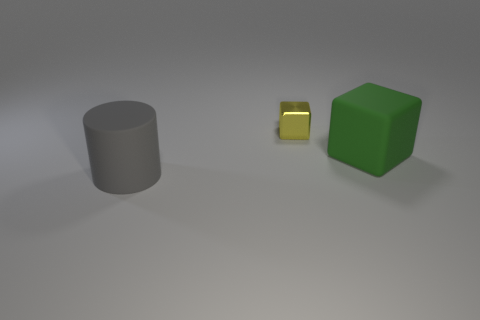There is a big thing on the right side of the matte cylinder; is it the same shape as the tiny yellow metallic object behind the cylinder?
Offer a very short reply. Yes. Are there any tiny purple rubber things?
Make the answer very short. No. There is another object that is the same shape as the small yellow shiny object; what color is it?
Offer a very short reply. Green. The rubber cylinder that is the same size as the green thing is what color?
Your response must be concise. Gray. Does the big cylinder have the same material as the large cube?
Ensure brevity in your answer.  Yes. Does the large block have the same color as the metallic thing?
Your answer should be very brief. No. There is a thing that is in front of the green rubber object; what material is it?
Offer a terse response. Rubber. What number of tiny things are either green rubber objects or yellow shiny cylinders?
Provide a succinct answer. 0. Is there a green object that has the same material as the big cylinder?
Offer a terse response. Yes. There is a rubber thing that is behind the gray matte object; is it the same size as the gray matte cylinder?
Give a very brief answer. Yes. 